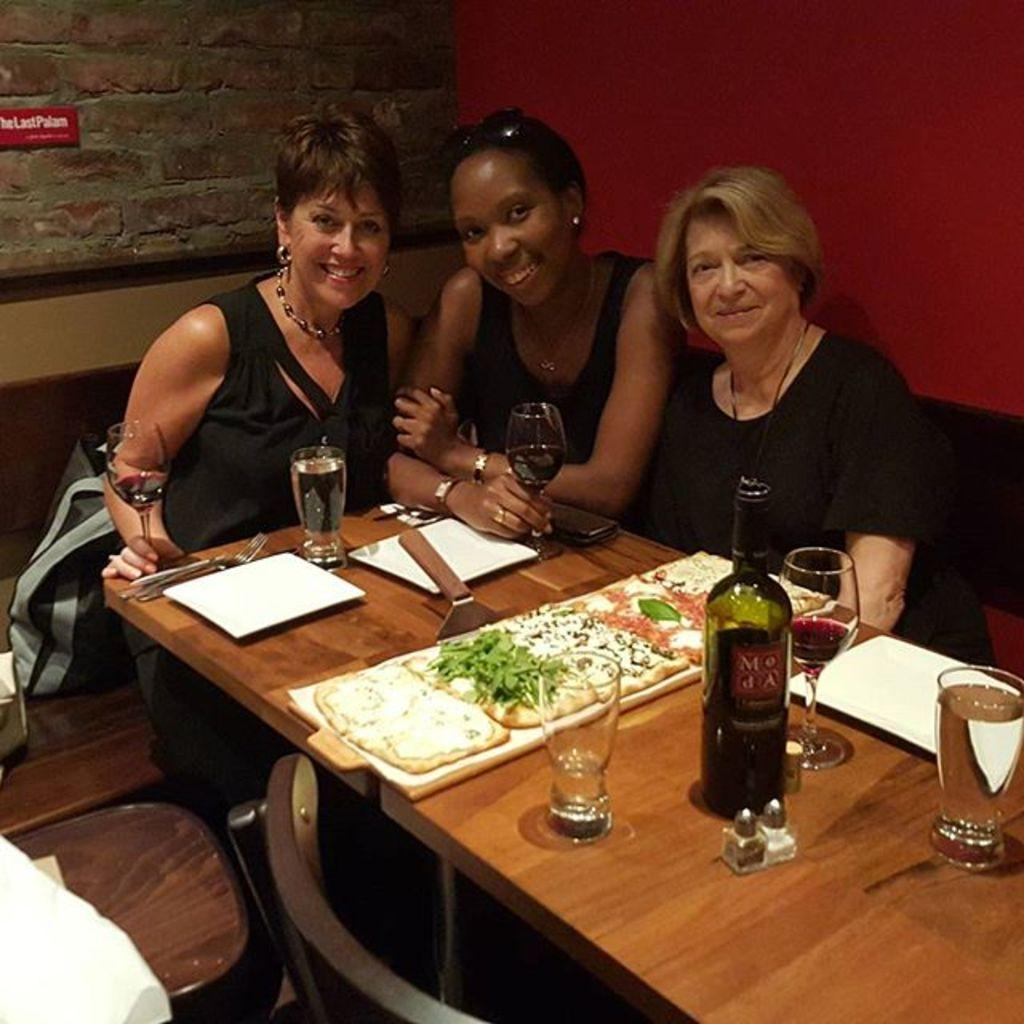How many women are sitting on the chair in the image? There are three women sitting on a chair in the image. What is in front of the women? There is a table in front of the women. What can be seen on the table? There is a glass, a bottle, a wine glass, food, a fork, and a plate on the table. What type of grape is being used as a comb in the image? There is no grape or comb present in the image. 